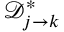<formula> <loc_0><loc_0><loc_500><loc_500>\mathcal { D } _ { j \rightarrow k } ^ { * }</formula> 